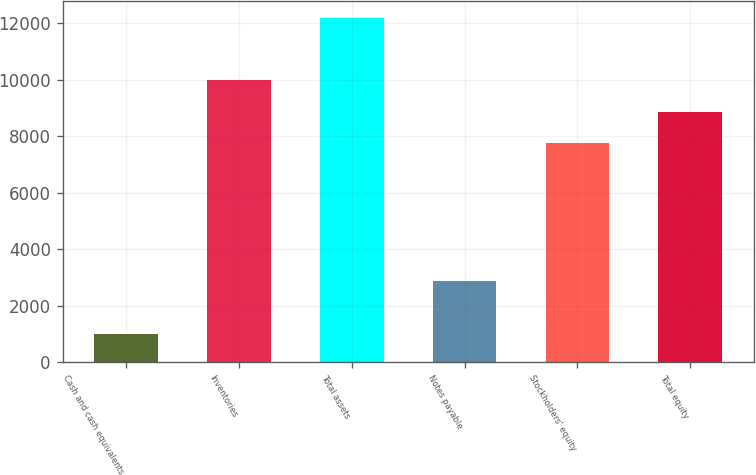<chart> <loc_0><loc_0><loc_500><loc_500><bar_chart><fcel>Cash and cash equivalents<fcel>Inventories<fcel>Total assets<fcel>Notes payable<fcel>Stockholders' equity<fcel>Total equity<nl><fcel>1007.8<fcel>9982.46<fcel>12184.6<fcel>2871.6<fcel>7747.1<fcel>8864.78<nl></chart> 